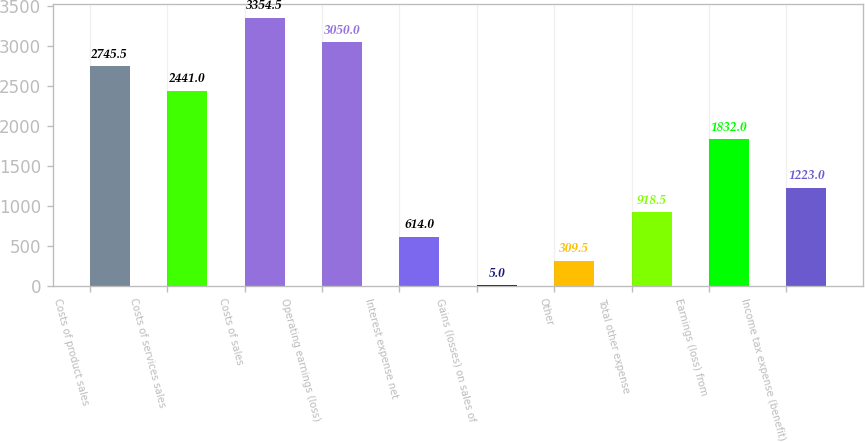Convert chart to OTSL. <chart><loc_0><loc_0><loc_500><loc_500><bar_chart><fcel>Costs of product sales<fcel>Costs of services sales<fcel>Costs of sales<fcel>Operating earnings (loss)<fcel>Interest expense net<fcel>Gains (losses) on sales of<fcel>Other<fcel>Total other expense<fcel>Earnings (loss) from<fcel>Income tax expense (benefit)<nl><fcel>2745.5<fcel>2441<fcel>3354.5<fcel>3050<fcel>614<fcel>5<fcel>309.5<fcel>918.5<fcel>1832<fcel>1223<nl></chart> 